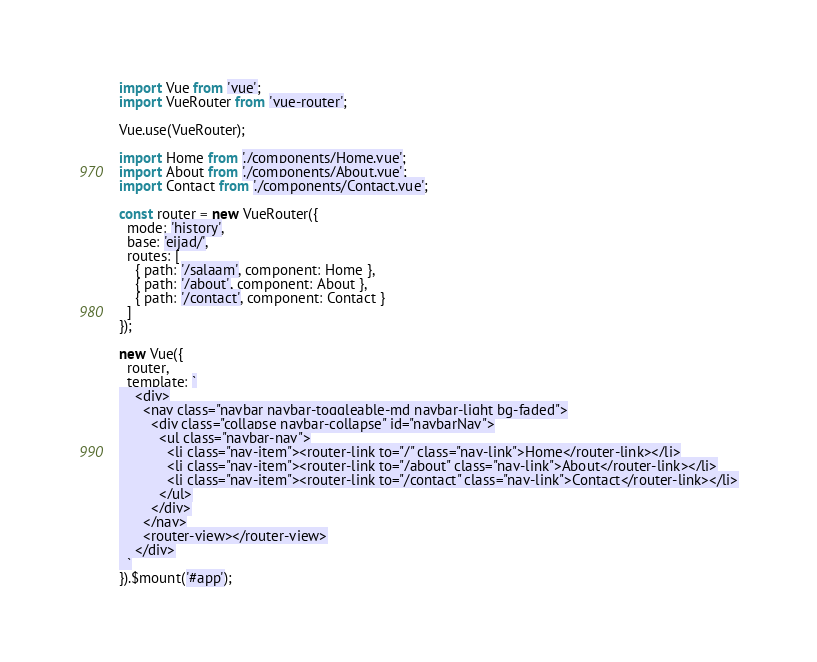Convert code to text. <code><loc_0><loc_0><loc_500><loc_500><_JavaScript_>import Vue from 'vue';
import VueRouter from 'vue-router';

Vue.use(VueRouter);

import Home from './components/Home.vue';
import About from './components/About.vue';
import Contact from './components/Contact.vue';

const router = new VueRouter({
  mode: 'history',
  base: 'eijad/',
  routes: [
    { path: '/salaam', component: Home },
    { path: '/about', component: About },
    { path: '/contact', component: Contact }
  ]
});

new Vue({
  router,
  template: `
    <div>
      <nav class="navbar navbar-toggleable-md navbar-light bg-faded">
        <div class="collapse navbar-collapse" id="navbarNav">
          <ul class="navbar-nav">
            <li class="nav-item"><router-link to="/" class="nav-link">Home</router-link></li>
            <li class="nav-item"><router-link to="/about" class="nav-link">About</router-link></li>
            <li class="nav-item"><router-link to="/contact" class="nav-link">Contact</router-link></li>
          </ul>
        </div>
      </nav>
      <router-view></router-view>
    </div>
  `
}).$mount('#app');
</code> 